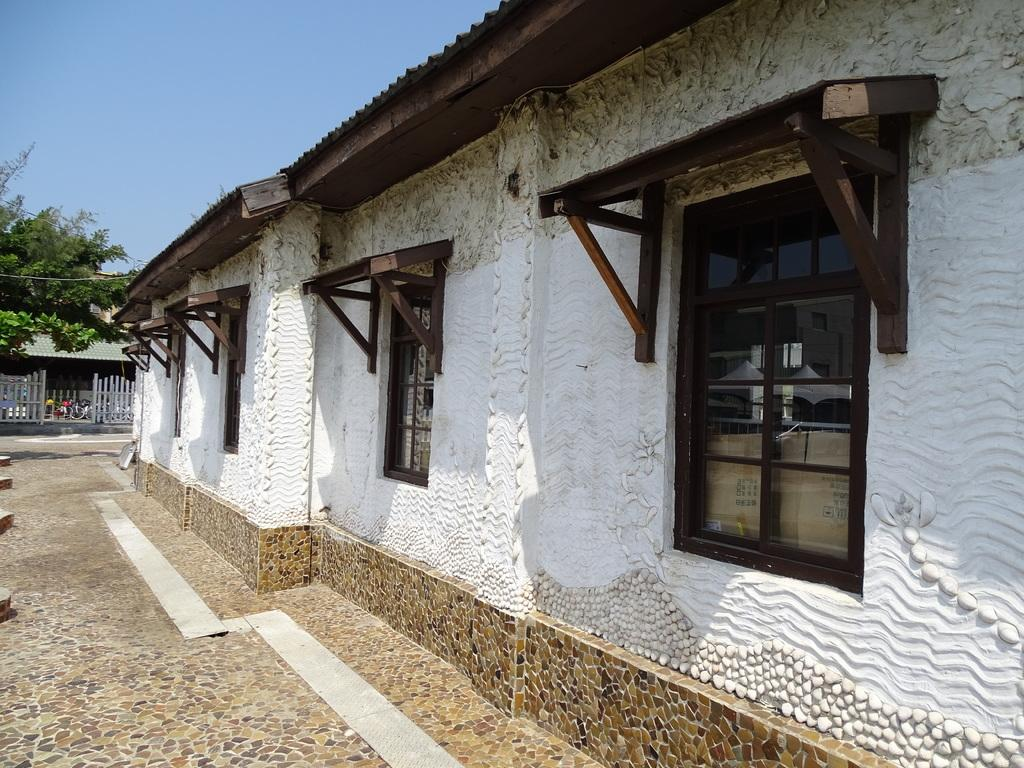What type of structures can be seen in the image? There are buildings in the image. What feature is visible on the buildings? There are windows visible in the image. What type of barrier is present in the image? There is a fence in the image. What type of vegetation is present in the image? There are trees in the image. What part of the natural environment is visible in the image? The sky is visible in the image. Based on the visibility of the sky and the presence of natural light, when do you think the image was taken? The image was likely taken during the day. What flavor of ice cream is being sold at the shop in the image? There is no shop or ice cream present in the image; it features buildings, windows, a fence, trees, and the sky. 